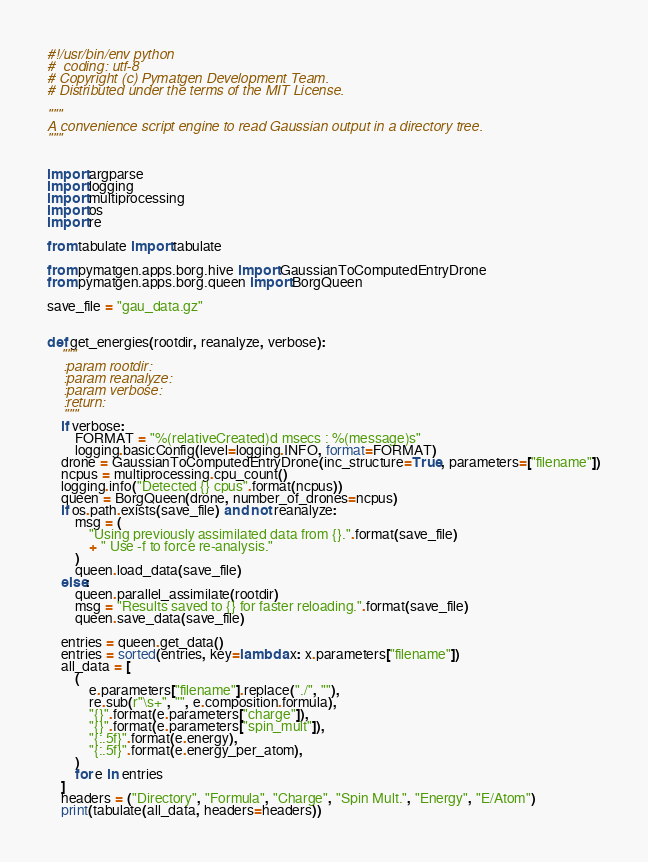Convert code to text. <code><loc_0><loc_0><loc_500><loc_500><_Python_>#!/usr/bin/env python
#  coding: utf-8
# Copyright (c) Pymatgen Development Team.
# Distributed under the terms of the MIT License.

"""
A convenience script engine to read Gaussian output in a directory tree.
"""


import argparse
import logging
import multiprocessing
import os
import re

from tabulate import tabulate

from pymatgen.apps.borg.hive import GaussianToComputedEntryDrone
from pymatgen.apps.borg.queen import BorgQueen

save_file = "gau_data.gz"


def get_energies(rootdir, reanalyze, verbose):
    """
    :param rootdir:
    :param reanalyze:
    :param verbose:
    :return:
    """
    if verbose:
        FORMAT = "%(relativeCreated)d msecs : %(message)s"
        logging.basicConfig(level=logging.INFO, format=FORMAT)
    drone = GaussianToComputedEntryDrone(inc_structure=True, parameters=["filename"])
    ncpus = multiprocessing.cpu_count()
    logging.info("Detected {} cpus".format(ncpus))
    queen = BorgQueen(drone, number_of_drones=ncpus)
    if os.path.exists(save_file) and not reanalyze:
        msg = (
            "Using previously assimilated data from {}.".format(save_file)
            + " Use -f to force re-analysis."
        )
        queen.load_data(save_file)
    else:
        queen.parallel_assimilate(rootdir)
        msg = "Results saved to {} for faster reloading.".format(save_file)
        queen.save_data(save_file)

    entries = queen.get_data()
    entries = sorted(entries, key=lambda x: x.parameters["filename"])
    all_data = [
        (
            e.parameters["filename"].replace("./", ""),
            re.sub(r"\s+", "", e.composition.formula),
            "{}".format(e.parameters["charge"]),
            "{}".format(e.parameters["spin_mult"]),
            "{:.5f}".format(e.energy),
            "{:.5f}".format(e.energy_per_atom),
        )
        for e in entries
    ]
    headers = ("Directory", "Formula", "Charge", "Spin Mult.", "Energy", "E/Atom")
    print(tabulate(all_data, headers=headers))</code> 